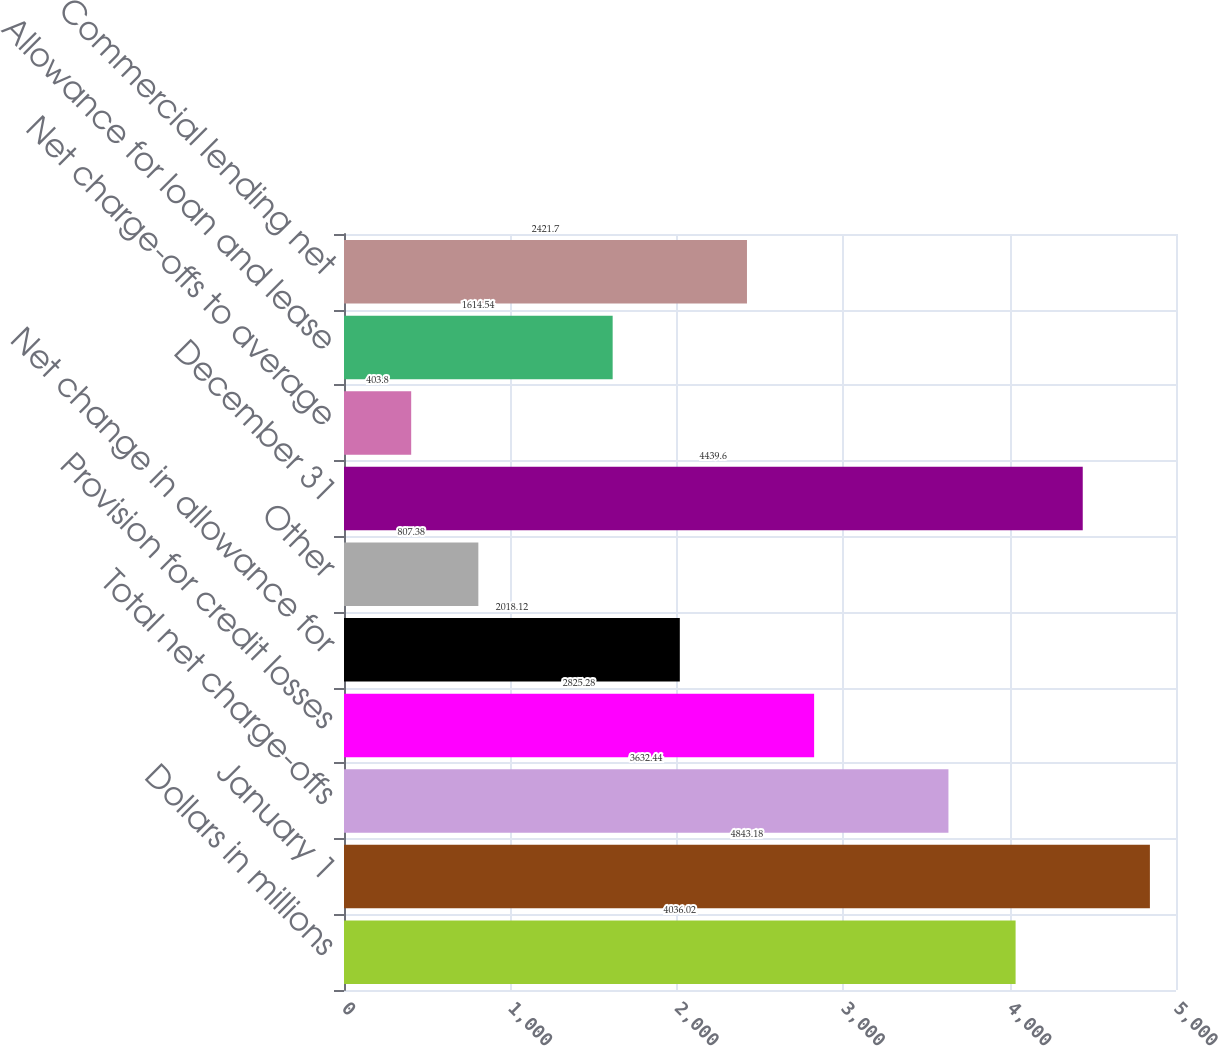<chart> <loc_0><loc_0><loc_500><loc_500><bar_chart><fcel>Dollars in millions<fcel>January 1<fcel>Total net charge-offs<fcel>Provision for credit losses<fcel>Net change in allowance for<fcel>Other<fcel>December 31<fcel>Net charge-offs to average<fcel>Allowance for loan and lease<fcel>Commercial lending net<nl><fcel>4036.02<fcel>4843.18<fcel>3632.44<fcel>2825.28<fcel>2018.12<fcel>807.38<fcel>4439.6<fcel>403.8<fcel>1614.54<fcel>2421.7<nl></chart> 